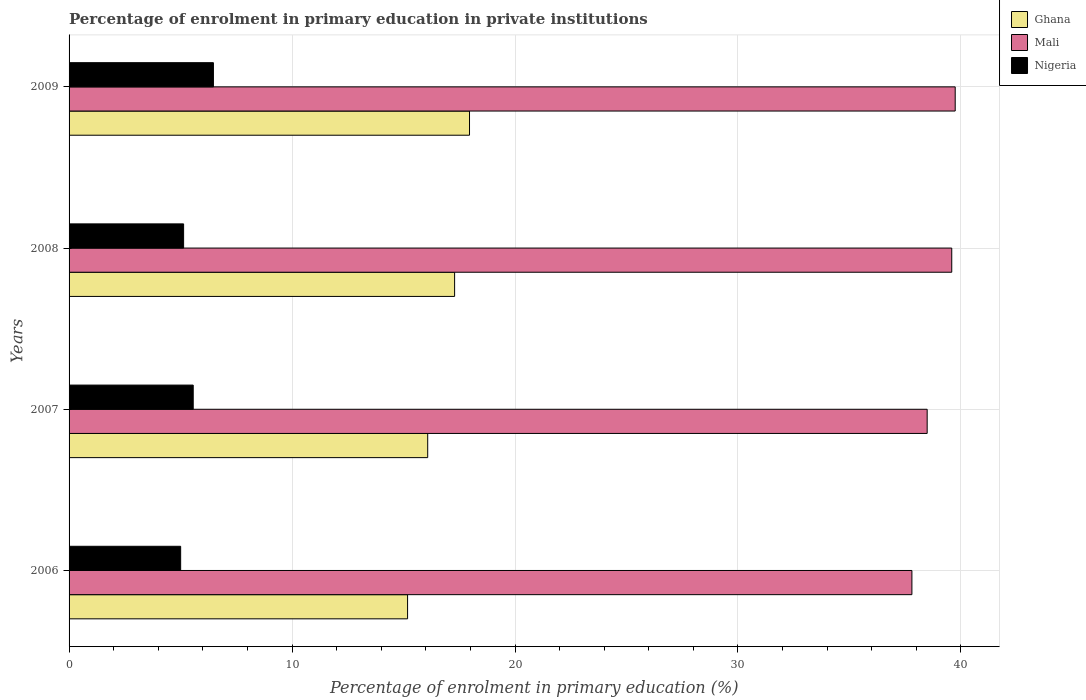How many bars are there on the 1st tick from the top?
Make the answer very short. 3. How many bars are there on the 1st tick from the bottom?
Your answer should be very brief. 3. What is the percentage of enrolment in primary education in Ghana in 2006?
Your answer should be compact. 15.18. Across all years, what is the maximum percentage of enrolment in primary education in Mali?
Offer a terse response. 39.74. Across all years, what is the minimum percentage of enrolment in primary education in Ghana?
Offer a very short reply. 15.18. In which year was the percentage of enrolment in primary education in Nigeria maximum?
Keep it short and to the point. 2009. In which year was the percentage of enrolment in primary education in Nigeria minimum?
Your answer should be compact. 2006. What is the total percentage of enrolment in primary education in Nigeria in the graph?
Your answer should be very brief. 22.18. What is the difference between the percentage of enrolment in primary education in Nigeria in 2008 and that in 2009?
Your response must be concise. -1.34. What is the difference between the percentage of enrolment in primary education in Mali in 2009 and the percentage of enrolment in primary education in Ghana in 2008?
Keep it short and to the point. 22.45. What is the average percentage of enrolment in primary education in Mali per year?
Your answer should be compact. 38.9. In the year 2007, what is the difference between the percentage of enrolment in primary education in Ghana and percentage of enrolment in primary education in Nigeria?
Keep it short and to the point. 10.52. In how many years, is the percentage of enrolment in primary education in Ghana greater than 18 %?
Make the answer very short. 0. What is the ratio of the percentage of enrolment in primary education in Ghana in 2006 to that in 2007?
Give a very brief answer. 0.94. What is the difference between the highest and the second highest percentage of enrolment in primary education in Mali?
Provide a short and direct response. 0.15. What is the difference between the highest and the lowest percentage of enrolment in primary education in Nigeria?
Ensure brevity in your answer.  1.47. Is the sum of the percentage of enrolment in primary education in Ghana in 2006 and 2008 greater than the maximum percentage of enrolment in primary education in Nigeria across all years?
Provide a succinct answer. Yes. What does the 3rd bar from the top in 2006 represents?
Your response must be concise. Ghana. What does the 2nd bar from the bottom in 2009 represents?
Your response must be concise. Mali. Is it the case that in every year, the sum of the percentage of enrolment in primary education in Nigeria and percentage of enrolment in primary education in Ghana is greater than the percentage of enrolment in primary education in Mali?
Your answer should be very brief. No. How many bars are there?
Offer a terse response. 12. Are all the bars in the graph horizontal?
Your answer should be very brief. Yes. Does the graph contain any zero values?
Keep it short and to the point. No. Where does the legend appear in the graph?
Provide a succinct answer. Top right. How many legend labels are there?
Provide a short and direct response. 3. What is the title of the graph?
Your answer should be compact. Percentage of enrolment in primary education in private institutions. What is the label or title of the X-axis?
Your response must be concise. Percentage of enrolment in primary education (%). What is the Percentage of enrolment in primary education (%) in Ghana in 2006?
Your answer should be very brief. 15.18. What is the Percentage of enrolment in primary education (%) in Mali in 2006?
Offer a very short reply. 37.8. What is the Percentage of enrolment in primary education (%) of Nigeria in 2006?
Give a very brief answer. 5. What is the Percentage of enrolment in primary education (%) in Ghana in 2007?
Offer a very short reply. 16.08. What is the Percentage of enrolment in primary education (%) in Mali in 2007?
Make the answer very short. 38.48. What is the Percentage of enrolment in primary education (%) in Nigeria in 2007?
Provide a succinct answer. 5.57. What is the Percentage of enrolment in primary education (%) in Ghana in 2008?
Make the answer very short. 17.29. What is the Percentage of enrolment in primary education (%) of Mali in 2008?
Provide a short and direct response. 39.59. What is the Percentage of enrolment in primary education (%) of Nigeria in 2008?
Your response must be concise. 5.14. What is the Percentage of enrolment in primary education (%) of Ghana in 2009?
Provide a short and direct response. 17.96. What is the Percentage of enrolment in primary education (%) in Mali in 2009?
Your answer should be compact. 39.74. What is the Percentage of enrolment in primary education (%) of Nigeria in 2009?
Make the answer very short. 6.47. Across all years, what is the maximum Percentage of enrolment in primary education (%) of Ghana?
Provide a short and direct response. 17.96. Across all years, what is the maximum Percentage of enrolment in primary education (%) in Mali?
Offer a terse response. 39.74. Across all years, what is the maximum Percentage of enrolment in primary education (%) in Nigeria?
Keep it short and to the point. 6.47. Across all years, what is the minimum Percentage of enrolment in primary education (%) in Ghana?
Make the answer very short. 15.18. Across all years, what is the minimum Percentage of enrolment in primary education (%) in Mali?
Give a very brief answer. 37.8. Across all years, what is the minimum Percentage of enrolment in primary education (%) of Nigeria?
Your response must be concise. 5. What is the total Percentage of enrolment in primary education (%) in Ghana in the graph?
Your answer should be compact. 66.52. What is the total Percentage of enrolment in primary education (%) of Mali in the graph?
Keep it short and to the point. 155.62. What is the total Percentage of enrolment in primary education (%) in Nigeria in the graph?
Offer a terse response. 22.18. What is the difference between the Percentage of enrolment in primary education (%) in Ghana in 2006 and that in 2007?
Your answer should be compact. -0.9. What is the difference between the Percentage of enrolment in primary education (%) in Mali in 2006 and that in 2007?
Your answer should be compact. -0.68. What is the difference between the Percentage of enrolment in primary education (%) in Nigeria in 2006 and that in 2007?
Give a very brief answer. -0.56. What is the difference between the Percentage of enrolment in primary education (%) of Ghana in 2006 and that in 2008?
Ensure brevity in your answer.  -2.11. What is the difference between the Percentage of enrolment in primary education (%) of Mali in 2006 and that in 2008?
Provide a succinct answer. -1.79. What is the difference between the Percentage of enrolment in primary education (%) in Nigeria in 2006 and that in 2008?
Offer a terse response. -0.13. What is the difference between the Percentage of enrolment in primary education (%) of Ghana in 2006 and that in 2009?
Make the answer very short. -2.78. What is the difference between the Percentage of enrolment in primary education (%) in Mali in 2006 and that in 2009?
Your answer should be compact. -1.94. What is the difference between the Percentage of enrolment in primary education (%) of Nigeria in 2006 and that in 2009?
Your response must be concise. -1.47. What is the difference between the Percentage of enrolment in primary education (%) in Ghana in 2007 and that in 2008?
Provide a short and direct response. -1.21. What is the difference between the Percentage of enrolment in primary education (%) of Mali in 2007 and that in 2008?
Your answer should be compact. -1.1. What is the difference between the Percentage of enrolment in primary education (%) of Nigeria in 2007 and that in 2008?
Keep it short and to the point. 0.43. What is the difference between the Percentage of enrolment in primary education (%) in Ghana in 2007 and that in 2009?
Provide a succinct answer. -1.88. What is the difference between the Percentage of enrolment in primary education (%) of Mali in 2007 and that in 2009?
Give a very brief answer. -1.26. What is the difference between the Percentage of enrolment in primary education (%) in Nigeria in 2007 and that in 2009?
Provide a short and direct response. -0.91. What is the difference between the Percentage of enrolment in primary education (%) in Ghana in 2008 and that in 2009?
Your response must be concise. -0.67. What is the difference between the Percentage of enrolment in primary education (%) in Mali in 2008 and that in 2009?
Make the answer very short. -0.15. What is the difference between the Percentage of enrolment in primary education (%) of Nigeria in 2008 and that in 2009?
Offer a terse response. -1.34. What is the difference between the Percentage of enrolment in primary education (%) in Ghana in 2006 and the Percentage of enrolment in primary education (%) in Mali in 2007?
Keep it short and to the point. -23.3. What is the difference between the Percentage of enrolment in primary education (%) in Ghana in 2006 and the Percentage of enrolment in primary education (%) in Nigeria in 2007?
Make the answer very short. 9.61. What is the difference between the Percentage of enrolment in primary education (%) in Mali in 2006 and the Percentage of enrolment in primary education (%) in Nigeria in 2007?
Give a very brief answer. 32.23. What is the difference between the Percentage of enrolment in primary education (%) of Ghana in 2006 and the Percentage of enrolment in primary education (%) of Mali in 2008?
Your answer should be very brief. -24.41. What is the difference between the Percentage of enrolment in primary education (%) of Ghana in 2006 and the Percentage of enrolment in primary education (%) of Nigeria in 2008?
Ensure brevity in your answer.  10.05. What is the difference between the Percentage of enrolment in primary education (%) of Mali in 2006 and the Percentage of enrolment in primary education (%) of Nigeria in 2008?
Your answer should be very brief. 32.66. What is the difference between the Percentage of enrolment in primary education (%) in Ghana in 2006 and the Percentage of enrolment in primary education (%) in Mali in 2009?
Offer a very short reply. -24.56. What is the difference between the Percentage of enrolment in primary education (%) in Ghana in 2006 and the Percentage of enrolment in primary education (%) in Nigeria in 2009?
Give a very brief answer. 8.71. What is the difference between the Percentage of enrolment in primary education (%) in Mali in 2006 and the Percentage of enrolment in primary education (%) in Nigeria in 2009?
Provide a succinct answer. 31.33. What is the difference between the Percentage of enrolment in primary education (%) in Ghana in 2007 and the Percentage of enrolment in primary education (%) in Mali in 2008?
Give a very brief answer. -23.5. What is the difference between the Percentage of enrolment in primary education (%) in Ghana in 2007 and the Percentage of enrolment in primary education (%) in Nigeria in 2008?
Your response must be concise. 10.95. What is the difference between the Percentage of enrolment in primary education (%) in Mali in 2007 and the Percentage of enrolment in primary education (%) in Nigeria in 2008?
Ensure brevity in your answer.  33.35. What is the difference between the Percentage of enrolment in primary education (%) in Ghana in 2007 and the Percentage of enrolment in primary education (%) in Mali in 2009?
Make the answer very short. -23.66. What is the difference between the Percentage of enrolment in primary education (%) of Ghana in 2007 and the Percentage of enrolment in primary education (%) of Nigeria in 2009?
Your answer should be very brief. 9.61. What is the difference between the Percentage of enrolment in primary education (%) of Mali in 2007 and the Percentage of enrolment in primary education (%) of Nigeria in 2009?
Give a very brief answer. 32.01. What is the difference between the Percentage of enrolment in primary education (%) in Ghana in 2008 and the Percentage of enrolment in primary education (%) in Mali in 2009?
Offer a very short reply. -22.45. What is the difference between the Percentage of enrolment in primary education (%) of Ghana in 2008 and the Percentage of enrolment in primary education (%) of Nigeria in 2009?
Give a very brief answer. 10.82. What is the difference between the Percentage of enrolment in primary education (%) in Mali in 2008 and the Percentage of enrolment in primary education (%) in Nigeria in 2009?
Give a very brief answer. 33.11. What is the average Percentage of enrolment in primary education (%) of Ghana per year?
Your answer should be very brief. 16.63. What is the average Percentage of enrolment in primary education (%) of Mali per year?
Give a very brief answer. 38.9. What is the average Percentage of enrolment in primary education (%) in Nigeria per year?
Keep it short and to the point. 5.55. In the year 2006, what is the difference between the Percentage of enrolment in primary education (%) in Ghana and Percentage of enrolment in primary education (%) in Mali?
Provide a succinct answer. -22.62. In the year 2006, what is the difference between the Percentage of enrolment in primary education (%) in Ghana and Percentage of enrolment in primary education (%) in Nigeria?
Make the answer very short. 10.18. In the year 2006, what is the difference between the Percentage of enrolment in primary education (%) in Mali and Percentage of enrolment in primary education (%) in Nigeria?
Your answer should be very brief. 32.8. In the year 2007, what is the difference between the Percentage of enrolment in primary education (%) of Ghana and Percentage of enrolment in primary education (%) of Mali?
Provide a short and direct response. -22.4. In the year 2007, what is the difference between the Percentage of enrolment in primary education (%) of Ghana and Percentage of enrolment in primary education (%) of Nigeria?
Ensure brevity in your answer.  10.52. In the year 2007, what is the difference between the Percentage of enrolment in primary education (%) in Mali and Percentage of enrolment in primary education (%) in Nigeria?
Offer a terse response. 32.92. In the year 2008, what is the difference between the Percentage of enrolment in primary education (%) of Ghana and Percentage of enrolment in primary education (%) of Mali?
Keep it short and to the point. -22.3. In the year 2008, what is the difference between the Percentage of enrolment in primary education (%) in Ghana and Percentage of enrolment in primary education (%) in Nigeria?
Offer a terse response. 12.15. In the year 2008, what is the difference between the Percentage of enrolment in primary education (%) of Mali and Percentage of enrolment in primary education (%) of Nigeria?
Provide a succinct answer. 34.45. In the year 2009, what is the difference between the Percentage of enrolment in primary education (%) of Ghana and Percentage of enrolment in primary education (%) of Mali?
Ensure brevity in your answer.  -21.78. In the year 2009, what is the difference between the Percentage of enrolment in primary education (%) of Ghana and Percentage of enrolment in primary education (%) of Nigeria?
Give a very brief answer. 11.49. In the year 2009, what is the difference between the Percentage of enrolment in primary education (%) in Mali and Percentage of enrolment in primary education (%) in Nigeria?
Your answer should be very brief. 33.27. What is the ratio of the Percentage of enrolment in primary education (%) of Ghana in 2006 to that in 2007?
Provide a short and direct response. 0.94. What is the ratio of the Percentage of enrolment in primary education (%) of Mali in 2006 to that in 2007?
Provide a succinct answer. 0.98. What is the ratio of the Percentage of enrolment in primary education (%) of Nigeria in 2006 to that in 2007?
Ensure brevity in your answer.  0.9. What is the ratio of the Percentage of enrolment in primary education (%) in Ghana in 2006 to that in 2008?
Offer a terse response. 0.88. What is the ratio of the Percentage of enrolment in primary education (%) of Mali in 2006 to that in 2008?
Ensure brevity in your answer.  0.95. What is the ratio of the Percentage of enrolment in primary education (%) in Nigeria in 2006 to that in 2008?
Your answer should be compact. 0.97. What is the ratio of the Percentage of enrolment in primary education (%) in Ghana in 2006 to that in 2009?
Make the answer very short. 0.85. What is the ratio of the Percentage of enrolment in primary education (%) of Mali in 2006 to that in 2009?
Give a very brief answer. 0.95. What is the ratio of the Percentage of enrolment in primary education (%) of Nigeria in 2006 to that in 2009?
Provide a succinct answer. 0.77. What is the ratio of the Percentage of enrolment in primary education (%) in Ghana in 2007 to that in 2008?
Offer a very short reply. 0.93. What is the ratio of the Percentage of enrolment in primary education (%) in Mali in 2007 to that in 2008?
Offer a terse response. 0.97. What is the ratio of the Percentage of enrolment in primary education (%) of Nigeria in 2007 to that in 2008?
Your answer should be compact. 1.08. What is the ratio of the Percentage of enrolment in primary education (%) in Ghana in 2007 to that in 2009?
Keep it short and to the point. 0.9. What is the ratio of the Percentage of enrolment in primary education (%) of Mali in 2007 to that in 2009?
Your answer should be very brief. 0.97. What is the ratio of the Percentage of enrolment in primary education (%) in Nigeria in 2007 to that in 2009?
Your answer should be compact. 0.86. What is the ratio of the Percentage of enrolment in primary education (%) of Ghana in 2008 to that in 2009?
Keep it short and to the point. 0.96. What is the ratio of the Percentage of enrolment in primary education (%) in Nigeria in 2008 to that in 2009?
Ensure brevity in your answer.  0.79. What is the difference between the highest and the second highest Percentage of enrolment in primary education (%) in Ghana?
Keep it short and to the point. 0.67. What is the difference between the highest and the second highest Percentage of enrolment in primary education (%) in Mali?
Give a very brief answer. 0.15. What is the difference between the highest and the second highest Percentage of enrolment in primary education (%) in Nigeria?
Your answer should be very brief. 0.91. What is the difference between the highest and the lowest Percentage of enrolment in primary education (%) in Ghana?
Ensure brevity in your answer.  2.78. What is the difference between the highest and the lowest Percentage of enrolment in primary education (%) of Mali?
Keep it short and to the point. 1.94. What is the difference between the highest and the lowest Percentage of enrolment in primary education (%) of Nigeria?
Provide a short and direct response. 1.47. 